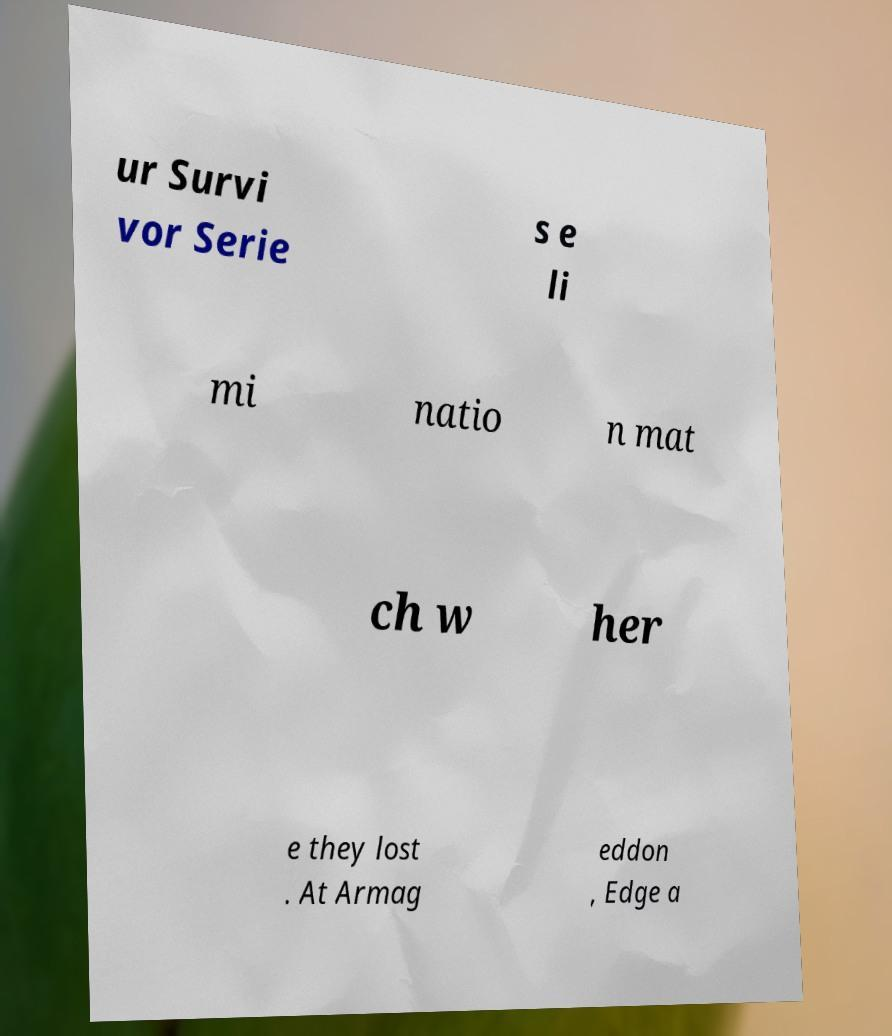I need the written content from this picture converted into text. Can you do that? ur Survi vor Serie s e li mi natio n mat ch w her e they lost . At Armag eddon , Edge a 